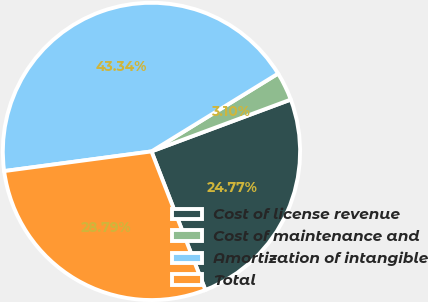<chart> <loc_0><loc_0><loc_500><loc_500><pie_chart><fcel>Cost of license revenue<fcel>Cost of maintenance and<fcel>Amortization of intangible<fcel>Total<nl><fcel>24.77%<fcel>3.1%<fcel>43.34%<fcel>28.79%<nl></chart> 